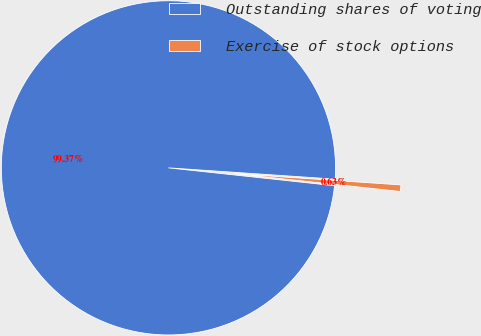Convert chart to OTSL. <chart><loc_0><loc_0><loc_500><loc_500><pie_chart><fcel>Outstanding shares of voting<fcel>Exercise of stock options<nl><fcel>99.37%<fcel>0.63%<nl></chart> 